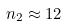Convert formula to latex. <formula><loc_0><loc_0><loc_500><loc_500>n _ { 2 } \approx 1 2</formula> 